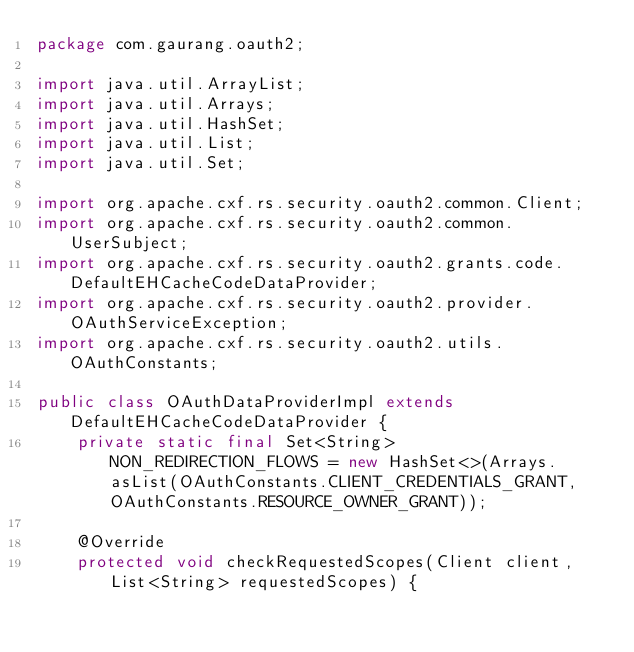Convert code to text. <code><loc_0><loc_0><loc_500><loc_500><_Java_>package com.gaurang.oauth2;

import java.util.ArrayList;
import java.util.Arrays;
import java.util.HashSet;
import java.util.List;
import java.util.Set;

import org.apache.cxf.rs.security.oauth2.common.Client;
import org.apache.cxf.rs.security.oauth2.common.UserSubject;
import org.apache.cxf.rs.security.oauth2.grants.code.DefaultEHCacheCodeDataProvider;
import org.apache.cxf.rs.security.oauth2.provider.OAuthServiceException;
import org.apache.cxf.rs.security.oauth2.utils.OAuthConstants;

public class OAuthDataProviderImpl extends DefaultEHCacheCodeDataProvider {
	private static final Set<String> NON_REDIRECTION_FLOWS = new HashSet<>(Arrays.asList(OAuthConstants.CLIENT_CREDENTIALS_GRANT, OAuthConstants.RESOURCE_OWNER_GRANT));

	@Override
	protected void checkRequestedScopes(Client client, List<String> requestedScopes) {</code> 